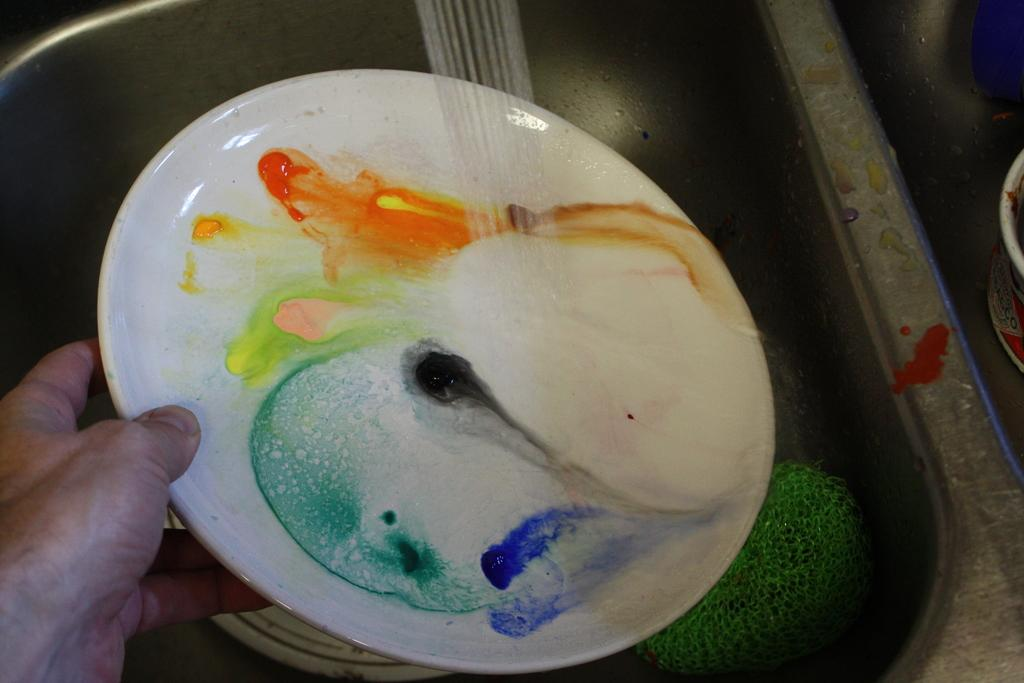What is the person in the image doing? The person is washing a plate. Where is the plate being washed? The plate is in a sink. What is the sink equipped with? The sink has a tap. What else can be found in the sink besides the plate? There is an object in the sink. What type of action is the person taking to catch fish in the image? There is no indication of fishing or any related action in the image; the person is washing a plate. 